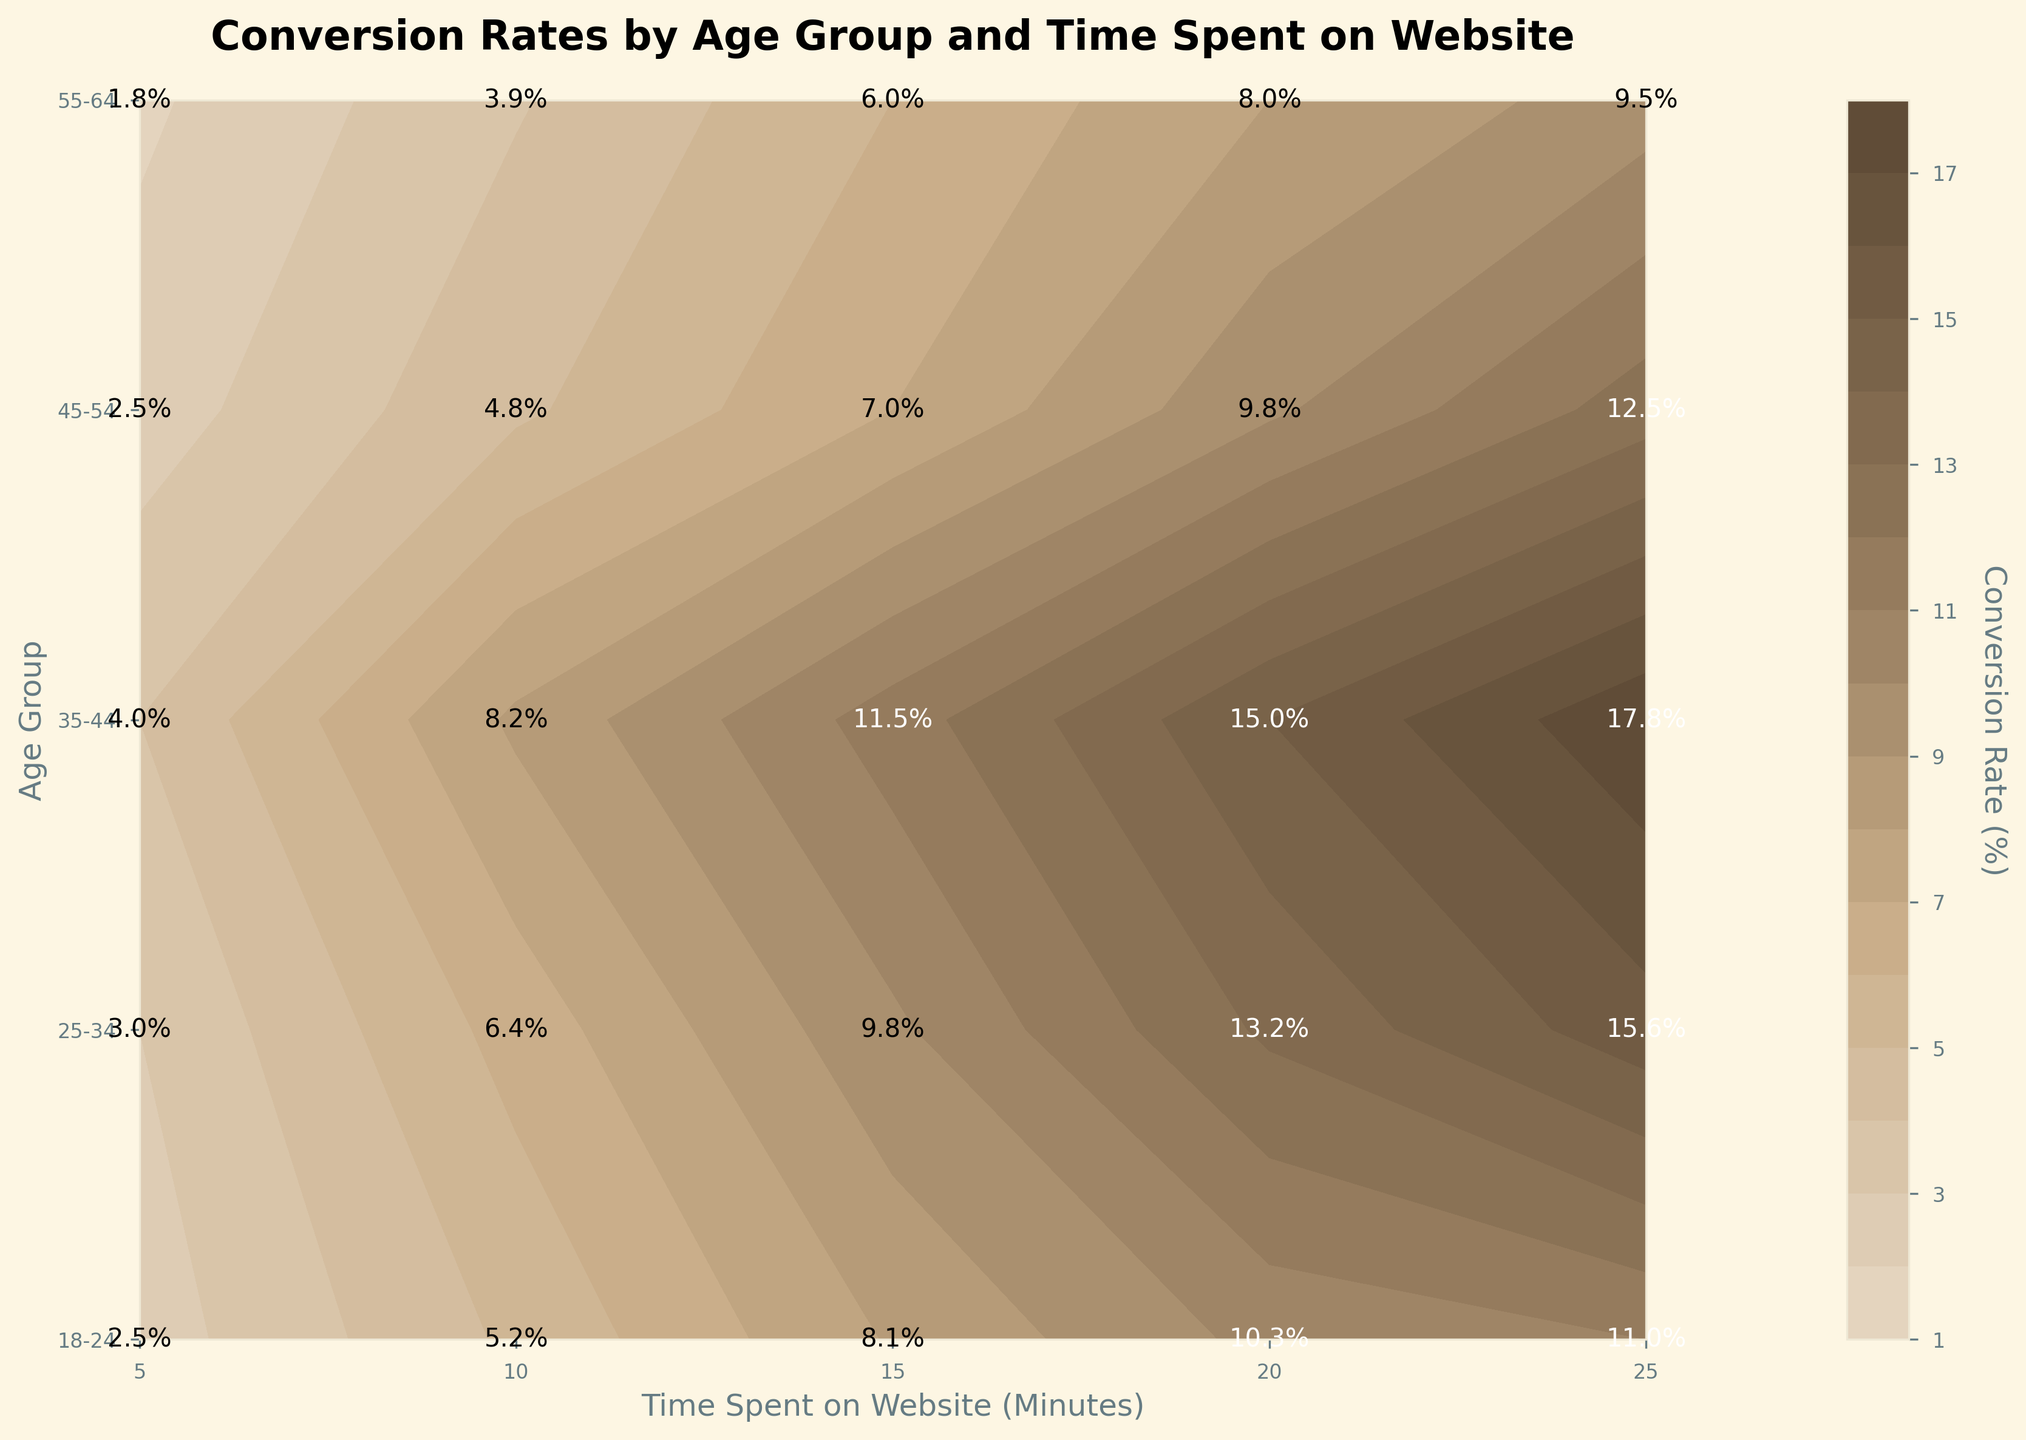What's the title of the figure? The title is usually placed at the top of the figure. From the data provided, and considering standard practices for figures, it should reflect the content depicted.
Answer: Conversion Rates by Age Group and Time Spent on Website What are the x-axis and y-axis labels? The labels for the axes are typically provided to explain what each axis represents. In this case, we note that the x-axis shows time spent on the website in minutes, and the y-axis shows different age groups.
Answer: Time Spent on Website (Minutes) and Age Group What does the color bar represent in the figure? The color bar is usually used to represent different values. By examining the description, it represents the conversion rate in percentages.
Answer: Conversion Rate (%) Which age group has the highest conversion rate for spending 15 minutes on the website? Look at the data points along the y-axis for "15 minutes" on the x-axis and compare the conversion rates. The highest value is for the 35-44 age group.
Answer: 35-44 At 25 minutes spent on the website, which age group shows the lowest conversion rate? Compare the conversion rates at 25 minutes for each age group. The lowest conversion rate is for the 55-64 age group.
Answer: 55-64 How does the conversion rate change for the 25-34 age group as time spent on the website increases? Look at the conversion rates for the 25-34 age group across different time intervals. It increases from 3.0% at 5 minutes to 15.6% at 25 minutes.
Answer: It increases At 20 minutes spent on the website, how much higher is the conversion rate for the 35-44 age group compared to the 18-24 age group? Compare the conversion rates for both age groups at 20 minutes. The 35-44 age group has a rate of 15.0%, and the 18-24 age group has 10.3%. Therefore, the difference is 15.0% - 10.3%.
Answer: 4.7% What age group shows the most significant increase in conversion rate when comparing 10 minutes to 20 minutes spent on the website? Calculate the difference in conversion rates between 20 minutes and 10 minutes for each age group. The 35-44 age group has the highest difference: 15.0% - 8.2% = 6.8%.
Answer: 35-44 For 5 minutes vs. 25 minutes spent on the website, which age group experiences the largest absolute increase in conversion rate? Calculate the difference in conversion rates between 25 minutes and 5 minutes for each age group. The 35-44 age group shows the largest increase: 17.8% - 4.0% = 13.8%.
Answer: 35-44 